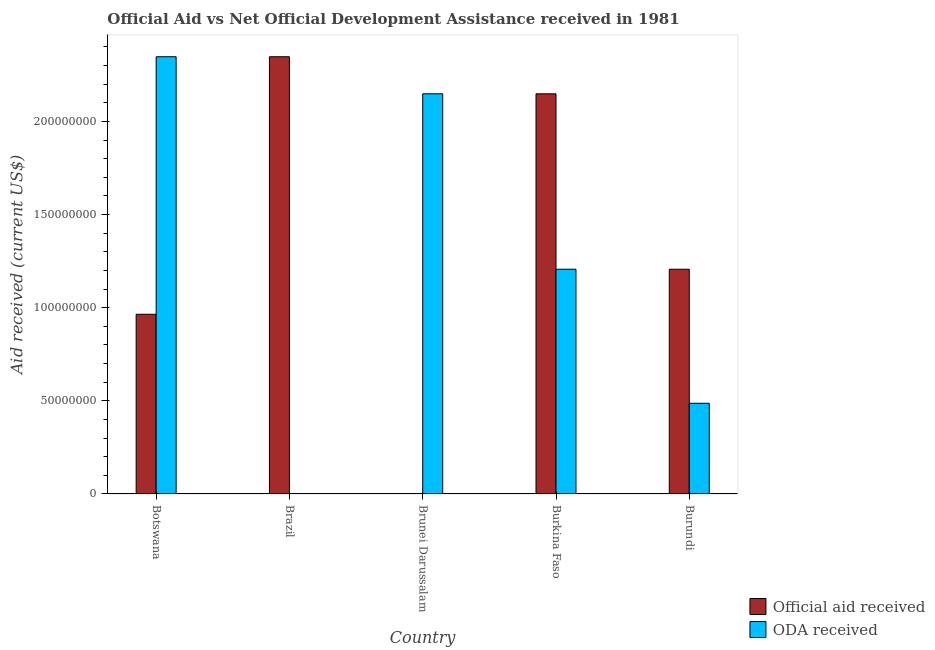How many groups of bars are there?
Make the answer very short. 5. Are the number of bars per tick equal to the number of legend labels?
Ensure brevity in your answer.  Yes. Are the number of bars on each tick of the X-axis equal?
Your answer should be very brief. Yes. How many bars are there on the 5th tick from the right?
Provide a short and direct response. 2. What is the label of the 5th group of bars from the left?
Provide a succinct answer. Burundi. What is the oda received in Botswana?
Provide a succinct answer. 2.35e+08. Across all countries, what is the maximum oda received?
Your answer should be very brief. 2.35e+08. Across all countries, what is the minimum official aid received?
Keep it short and to the point. 1.90e+05. In which country was the official aid received maximum?
Keep it short and to the point. Brazil. In which country was the official aid received minimum?
Your answer should be very brief. Brunei Darussalam. What is the total official aid received in the graph?
Your response must be concise. 6.67e+08. What is the difference between the oda received in Brazil and that in Burkina Faso?
Offer a very short reply. -1.20e+08. What is the average oda received per country?
Your answer should be compact. 1.24e+08. What is the difference between the official aid received and oda received in Brazil?
Give a very brief answer. 2.35e+08. What is the ratio of the oda received in Botswana to that in Burkina Faso?
Ensure brevity in your answer.  1.95. Is the oda received in Botswana less than that in Brazil?
Give a very brief answer. No. Is the difference between the official aid received in Brazil and Brunei Darussalam greater than the difference between the oda received in Brazil and Brunei Darussalam?
Offer a terse response. Yes. What is the difference between the highest and the second highest official aid received?
Offer a very short reply. 1.99e+07. What is the difference between the highest and the lowest oda received?
Provide a short and direct response. 2.35e+08. Is the sum of the oda received in Burkina Faso and Burundi greater than the maximum official aid received across all countries?
Make the answer very short. No. What does the 2nd bar from the left in Burundi represents?
Your answer should be very brief. ODA received. What does the 2nd bar from the right in Brunei Darussalam represents?
Provide a succinct answer. Official aid received. How many bars are there?
Offer a terse response. 10. What is the difference between two consecutive major ticks on the Y-axis?
Offer a terse response. 5.00e+07. Are the values on the major ticks of Y-axis written in scientific E-notation?
Your answer should be compact. No. Does the graph contain any zero values?
Make the answer very short. No. Does the graph contain grids?
Ensure brevity in your answer.  No. Where does the legend appear in the graph?
Give a very brief answer. Bottom right. How many legend labels are there?
Ensure brevity in your answer.  2. How are the legend labels stacked?
Your answer should be very brief. Vertical. What is the title of the graph?
Make the answer very short. Official Aid vs Net Official Development Assistance received in 1981 . What is the label or title of the X-axis?
Your answer should be compact. Country. What is the label or title of the Y-axis?
Keep it short and to the point. Aid received (current US$). What is the Aid received (current US$) of Official aid received in Botswana?
Ensure brevity in your answer.  9.65e+07. What is the Aid received (current US$) in ODA received in Botswana?
Provide a succinct answer. 2.35e+08. What is the Aid received (current US$) in Official aid received in Brazil?
Your answer should be compact. 2.35e+08. What is the Aid received (current US$) in ODA received in Brazil?
Your response must be concise. 1.90e+05. What is the Aid received (current US$) of ODA received in Brunei Darussalam?
Offer a terse response. 2.15e+08. What is the Aid received (current US$) in Official aid received in Burkina Faso?
Your answer should be compact. 2.15e+08. What is the Aid received (current US$) of ODA received in Burkina Faso?
Provide a short and direct response. 1.21e+08. What is the Aid received (current US$) of Official aid received in Burundi?
Your answer should be compact. 1.21e+08. What is the Aid received (current US$) of ODA received in Burundi?
Give a very brief answer. 4.87e+07. Across all countries, what is the maximum Aid received (current US$) in Official aid received?
Keep it short and to the point. 2.35e+08. Across all countries, what is the maximum Aid received (current US$) in ODA received?
Keep it short and to the point. 2.35e+08. Across all countries, what is the minimum Aid received (current US$) of Official aid received?
Offer a very short reply. 1.90e+05. What is the total Aid received (current US$) of Official aid received in the graph?
Offer a very short reply. 6.67e+08. What is the total Aid received (current US$) of ODA received in the graph?
Make the answer very short. 6.19e+08. What is the difference between the Aid received (current US$) of Official aid received in Botswana and that in Brazil?
Your response must be concise. -1.38e+08. What is the difference between the Aid received (current US$) of ODA received in Botswana and that in Brazil?
Your response must be concise. 2.35e+08. What is the difference between the Aid received (current US$) of Official aid received in Botswana and that in Brunei Darussalam?
Your answer should be compact. 9.63e+07. What is the difference between the Aid received (current US$) in ODA received in Botswana and that in Brunei Darussalam?
Give a very brief answer. 1.99e+07. What is the difference between the Aid received (current US$) in Official aid received in Botswana and that in Burkina Faso?
Your answer should be compact. -1.18e+08. What is the difference between the Aid received (current US$) in ODA received in Botswana and that in Burkina Faso?
Provide a succinct answer. 1.14e+08. What is the difference between the Aid received (current US$) in Official aid received in Botswana and that in Burundi?
Your answer should be compact. -2.42e+07. What is the difference between the Aid received (current US$) in ODA received in Botswana and that in Burundi?
Provide a succinct answer. 1.86e+08. What is the difference between the Aid received (current US$) of Official aid received in Brazil and that in Brunei Darussalam?
Provide a succinct answer. 2.35e+08. What is the difference between the Aid received (current US$) in ODA received in Brazil and that in Brunei Darussalam?
Your answer should be compact. -2.15e+08. What is the difference between the Aid received (current US$) in Official aid received in Brazil and that in Burkina Faso?
Make the answer very short. 1.99e+07. What is the difference between the Aid received (current US$) in ODA received in Brazil and that in Burkina Faso?
Ensure brevity in your answer.  -1.20e+08. What is the difference between the Aid received (current US$) of Official aid received in Brazil and that in Burundi?
Your response must be concise. 1.14e+08. What is the difference between the Aid received (current US$) in ODA received in Brazil and that in Burundi?
Provide a short and direct response. -4.85e+07. What is the difference between the Aid received (current US$) of Official aid received in Brunei Darussalam and that in Burkina Faso?
Make the answer very short. -2.15e+08. What is the difference between the Aid received (current US$) of ODA received in Brunei Darussalam and that in Burkina Faso?
Give a very brief answer. 9.42e+07. What is the difference between the Aid received (current US$) in Official aid received in Brunei Darussalam and that in Burundi?
Make the answer very short. -1.20e+08. What is the difference between the Aid received (current US$) in ODA received in Brunei Darussalam and that in Burundi?
Offer a very short reply. 1.66e+08. What is the difference between the Aid received (current US$) of Official aid received in Burkina Faso and that in Burundi?
Keep it short and to the point. 9.42e+07. What is the difference between the Aid received (current US$) of ODA received in Burkina Faso and that in Burundi?
Your answer should be very brief. 7.20e+07. What is the difference between the Aid received (current US$) in Official aid received in Botswana and the Aid received (current US$) in ODA received in Brazil?
Give a very brief answer. 9.63e+07. What is the difference between the Aid received (current US$) in Official aid received in Botswana and the Aid received (current US$) in ODA received in Brunei Darussalam?
Provide a short and direct response. -1.18e+08. What is the difference between the Aid received (current US$) in Official aid received in Botswana and the Aid received (current US$) in ODA received in Burkina Faso?
Keep it short and to the point. -2.42e+07. What is the difference between the Aid received (current US$) of Official aid received in Botswana and the Aid received (current US$) of ODA received in Burundi?
Your answer should be very brief. 4.78e+07. What is the difference between the Aid received (current US$) of Official aid received in Brazil and the Aid received (current US$) of ODA received in Brunei Darussalam?
Ensure brevity in your answer.  1.99e+07. What is the difference between the Aid received (current US$) in Official aid received in Brazil and the Aid received (current US$) in ODA received in Burkina Faso?
Keep it short and to the point. 1.14e+08. What is the difference between the Aid received (current US$) of Official aid received in Brazil and the Aid received (current US$) of ODA received in Burundi?
Ensure brevity in your answer.  1.86e+08. What is the difference between the Aid received (current US$) in Official aid received in Brunei Darussalam and the Aid received (current US$) in ODA received in Burkina Faso?
Give a very brief answer. -1.20e+08. What is the difference between the Aid received (current US$) of Official aid received in Brunei Darussalam and the Aid received (current US$) of ODA received in Burundi?
Provide a succinct answer. -4.85e+07. What is the difference between the Aid received (current US$) in Official aid received in Burkina Faso and the Aid received (current US$) in ODA received in Burundi?
Provide a succinct answer. 1.66e+08. What is the average Aid received (current US$) of Official aid received per country?
Keep it short and to the point. 1.33e+08. What is the average Aid received (current US$) in ODA received per country?
Your response must be concise. 1.24e+08. What is the difference between the Aid received (current US$) of Official aid received and Aid received (current US$) of ODA received in Botswana?
Offer a terse response. -1.38e+08. What is the difference between the Aid received (current US$) of Official aid received and Aid received (current US$) of ODA received in Brazil?
Your answer should be compact. 2.35e+08. What is the difference between the Aid received (current US$) of Official aid received and Aid received (current US$) of ODA received in Brunei Darussalam?
Your response must be concise. -2.15e+08. What is the difference between the Aid received (current US$) of Official aid received and Aid received (current US$) of ODA received in Burkina Faso?
Ensure brevity in your answer.  9.42e+07. What is the difference between the Aid received (current US$) in Official aid received and Aid received (current US$) in ODA received in Burundi?
Your response must be concise. 7.20e+07. What is the ratio of the Aid received (current US$) of Official aid received in Botswana to that in Brazil?
Your answer should be compact. 0.41. What is the ratio of the Aid received (current US$) in ODA received in Botswana to that in Brazil?
Provide a short and direct response. 1235.42. What is the ratio of the Aid received (current US$) of Official aid received in Botswana to that in Brunei Darussalam?
Provide a succinct answer. 507.74. What is the ratio of the Aid received (current US$) of ODA received in Botswana to that in Brunei Darussalam?
Offer a very short reply. 1.09. What is the ratio of the Aid received (current US$) of Official aid received in Botswana to that in Burkina Faso?
Make the answer very short. 0.45. What is the ratio of the Aid received (current US$) of ODA received in Botswana to that in Burkina Faso?
Your response must be concise. 1.95. What is the ratio of the Aid received (current US$) in Official aid received in Botswana to that in Burundi?
Offer a very short reply. 0.8. What is the ratio of the Aid received (current US$) in ODA received in Botswana to that in Burundi?
Ensure brevity in your answer.  4.82. What is the ratio of the Aid received (current US$) of Official aid received in Brazil to that in Brunei Darussalam?
Ensure brevity in your answer.  1235.42. What is the ratio of the Aid received (current US$) of ODA received in Brazil to that in Brunei Darussalam?
Give a very brief answer. 0. What is the ratio of the Aid received (current US$) of Official aid received in Brazil to that in Burkina Faso?
Ensure brevity in your answer.  1.09. What is the ratio of the Aid received (current US$) of ODA received in Brazil to that in Burkina Faso?
Give a very brief answer. 0. What is the ratio of the Aid received (current US$) in Official aid received in Brazil to that in Burundi?
Give a very brief answer. 1.95. What is the ratio of the Aid received (current US$) of ODA received in Brazil to that in Burundi?
Your response must be concise. 0. What is the ratio of the Aid received (current US$) in Official aid received in Brunei Darussalam to that in Burkina Faso?
Provide a short and direct response. 0. What is the ratio of the Aid received (current US$) of ODA received in Brunei Darussalam to that in Burkina Faso?
Your answer should be compact. 1.78. What is the ratio of the Aid received (current US$) of Official aid received in Brunei Darussalam to that in Burundi?
Ensure brevity in your answer.  0. What is the ratio of the Aid received (current US$) in ODA received in Brunei Darussalam to that in Burundi?
Your answer should be very brief. 4.41. What is the ratio of the Aid received (current US$) of Official aid received in Burkina Faso to that in Burundi?
Ensure brevity in your answer.  1.78. What is the ratio of the Aid received (current US$) of ODA received in Burkina Faso to that in Burundi?
Provide a short and direct response. 2.48. What is the difference between the highest and the second highest Aid received (current US$) in Official aid received?
Offer a terse response. 1.99e+07. What is the difference between the highest and the second highest Aid received (current US$) of ODA received?
Your response must be concise. 1.99e+07. What is the difference between the highest and the lowest Aid received (current US$) of Official aid received?
Your answer should be compact. 2.35e+08. What is the difference between the highest and the lowest Aid received (current US$) in ODA received?
Provide a short and direct response. 2.35e+08. 